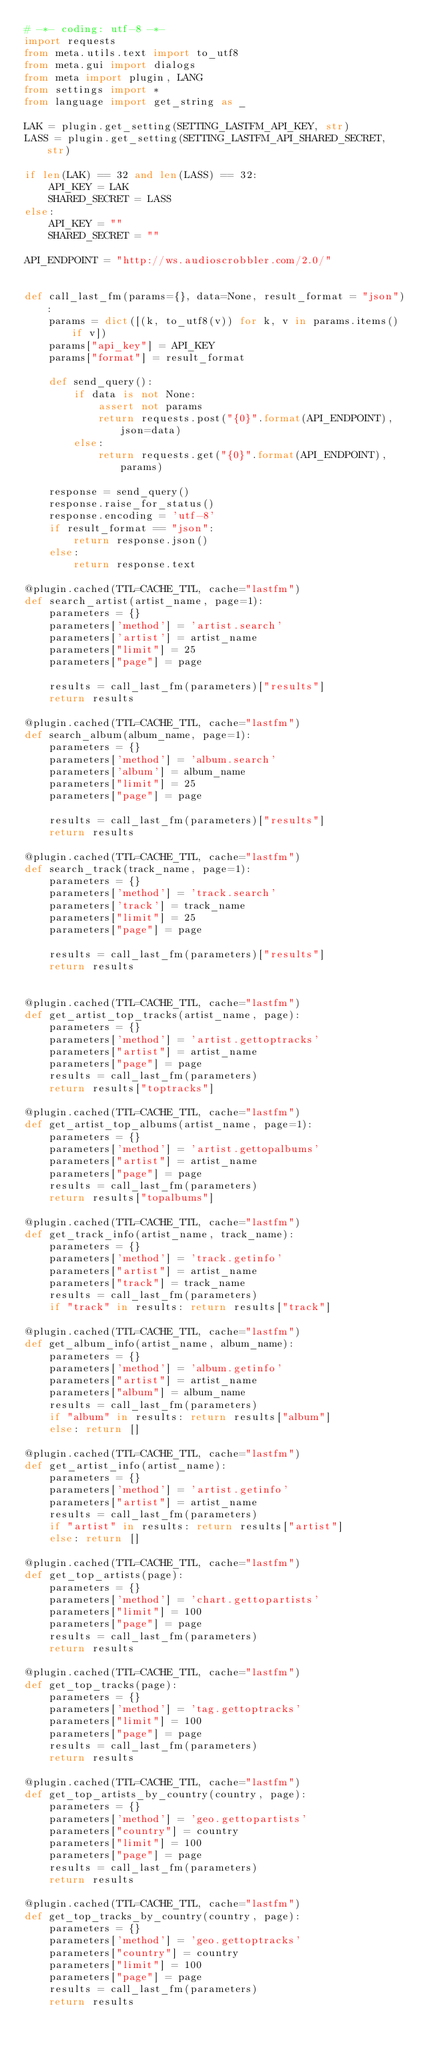<code> <loc_0><loc_0><loc_500><loc_500><_Python_># -*- coding: utf-8 -*-
import requests
from meta.utils.text import to_utf8
from meta.gui import dialogs
from meta import plugin, LANG
from settings import *
from language import get_string as _

LAK = plugin.get_setting(SETTING_LASTFM_API_KEY, str)
LASS = plugin.get_setting(SETTING_LASTFM_API_SHARED_SECRET, str)

if len(LAK) == 32 and len(LASS) == 32:
    API_KEY = LAK
    SHARED_SECRET = LASS
else:
    API_KEY = ""
    SHARED_SECRET = ""

API_ENDPOINT = "http://ws.audioscrobbler.com/2.0/"


def call_last_fm(params={}, data=None, result_format = "json"):
    params = dict([(k, to_utf8(v)) for k, v in params.items() if v])
    params["api_key"] = API_KEY
    params["format"] = result_format

    def send_query():
        if data is not None:
            assert not params
            return requests.post("{0}".format(API_ENDPOINT), json=data)
        else:
            return requests.get("{0}".format(API_ENDPOINT), params)

    response = send_query()
    response.raise_for_status()
    response.encoding = 'utf-8'
    if result_format == "json":
        return response.json()
    else:
        return response.text

@plugin.cached(TTL=CACHE_TTL, cache="lastfm")
def search_artist(artist_name, page=1):
    parameters = {}
    parameters['method'] = 'artist.search'
    parameters['artist'] = artist_name
    parameters["limit"] = 25
    parameters["page"] = page

    results = call_last_fm(parameters)["results"]
    return results

@plugin.cached(TTL=CACHE_TTL, cache="lastfm")
def search_album(album_name, page=1):
    parameters = {}
    parameters['method'] = 'album.search'
    parameters['album'] = album_name
    parameters["limit"] = 25
    parameters["page"] = page

    results = call_last_fm(parameters)["results"]
    return results

@plugin.cached(TTL=CACHE_TTL, cache="lastfm")
def search_track(track_name, page=1):
    parameters = {}
    parameters['method'] = 'track.search'
    parameters['track'] = track_name
    parameters["limit"] = 25
    parameters["page"] = page

    results = call_last_fm(parameters)["results"]
    return results


@plugin.cached(TTL=CACHE_TTL, cache="lastfm")
def get_artist_top_tracks(artist_name, page):
    parameters = {}
    parameters['method'] = 'artist.gettoptracks'
    parameters["artist"] = artist_name
    parameters["page"] = page
    results = call_last_fm(parameters)
    return results["toptracks"]

@plugin.cached(TTL=CACHE_TTL, cache="lastfm")
def get_artist_top_albums(artist_name, page=1):
    parameters = {}
    parameters['method'] = 'artist.gettopalbums'
    parameters["artist"] = artist_name
    parameters["page"] = page
    results = call_last_fm(parameters)
    return results["topalbums"]

@plugin.cached(TTL=CACHE_TTL, cache="lastfm")
def get_track_info(artist_name, track_name):
    parameters = {}
    parameters['method'] = 'track.getinfo'
    parameters["artist"] = artist_name
    parameters["track"] = track_name
    results = call_last_fm(parameters)
    if "track" in results: return results["track"]

@plugin.cached(TTL=CACHE_TTL, cache="lastfm")
def get_album_info(artist_name, album_name):
    parameters = {}
    parameters['method'] = 'album.getinfo'
    parameters["artist"] = artist_name
    parameters["album"] = album_name
    results = call_last_fm(parameters)
    if "album" in results: return results["album"]
    else: return []

@plugin.cached(TTL=CACHE_TTL, cache="lastfm")
def get_artist_info(artist_name):
    parameters = {}
    parameters['method'] = 'artist.getinfo'
    parameters["artist"] = artist_name
    results = call_last_fm(parameters)
    if "artist" in results: return results["artist"]
    else: return []

@plugin.cached(TTL=CACHE_TTL, cache="lastfm")
def get_top_artists(page):
    parameters = {}
    parameters['method'] = 'chart.gettopartists'
    parameters["limit"] = 100
    parameters["page"] = page
    results = call_last_fm(parameters)
    return results

@plugin.cached(TTL=CACHE_TTL, cache="lastfm")
def get_top_tracks(page):
    parameters = {}
    parameters['method'] = 'tag.gettoptracks'
    parameters["limit"] = 100
    parameters["page"] = page
    results = call_last_fm(parameters)
    return results

@plugin.cached(TTL=CACHE_TTL, cache="lastfm")
def get_top_artists_by_country(country, page):
    parameters = {}
    parameters['method'] = 'geo.gettopartists'
    parameters["country"] = country
    parameters["limit"] = 100
    parameters["page"] = page
    results = call_last_fm(parameters)
    return results

@plugin.cached(TTL=CACHE_TTL, cache="lastfm")
def get_top_tracks_by_country(country, page):
    parameters = {}
    parameters['method'] = 'geo.gettoptracks'
    parameters["country"] = country
    parameters["limit"] = 100
    parameters["page"] = page
    results = call_last_fm(parameters)
    return results
</code> 